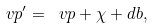Convert formula to latex. <formula><loc_0><loc_0><loc_500><loc_500>\ v p ^ { \prime } = \ v p + \chi + d b ,</formula> 